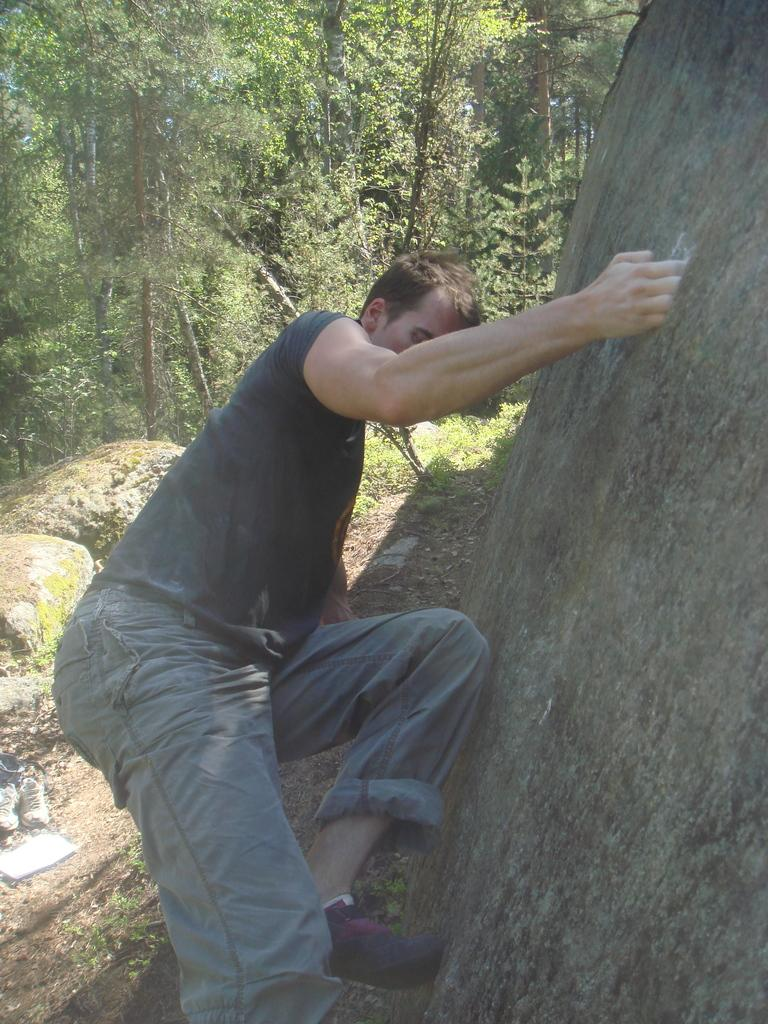What is the person in the image doing? There is a person climbing the hill in the image. What type of terrain can be seen in the image? Rocks are visible in the image. What item related to footwear is present in the image? A pair of shoes is present in the image. What object related to reading is visible in the image? There is a book in the image. What type of vegetation is visible in the image? Grass is visible in the image. What type of plant life is present in the image? Trees are present in the image. Can you tell me how many actors are visible in the image? There are no actors present in the image; it features a person climbing a hill. What type of breath is being taken by the person in the image? There is no indication of the person's breathing in the image. 